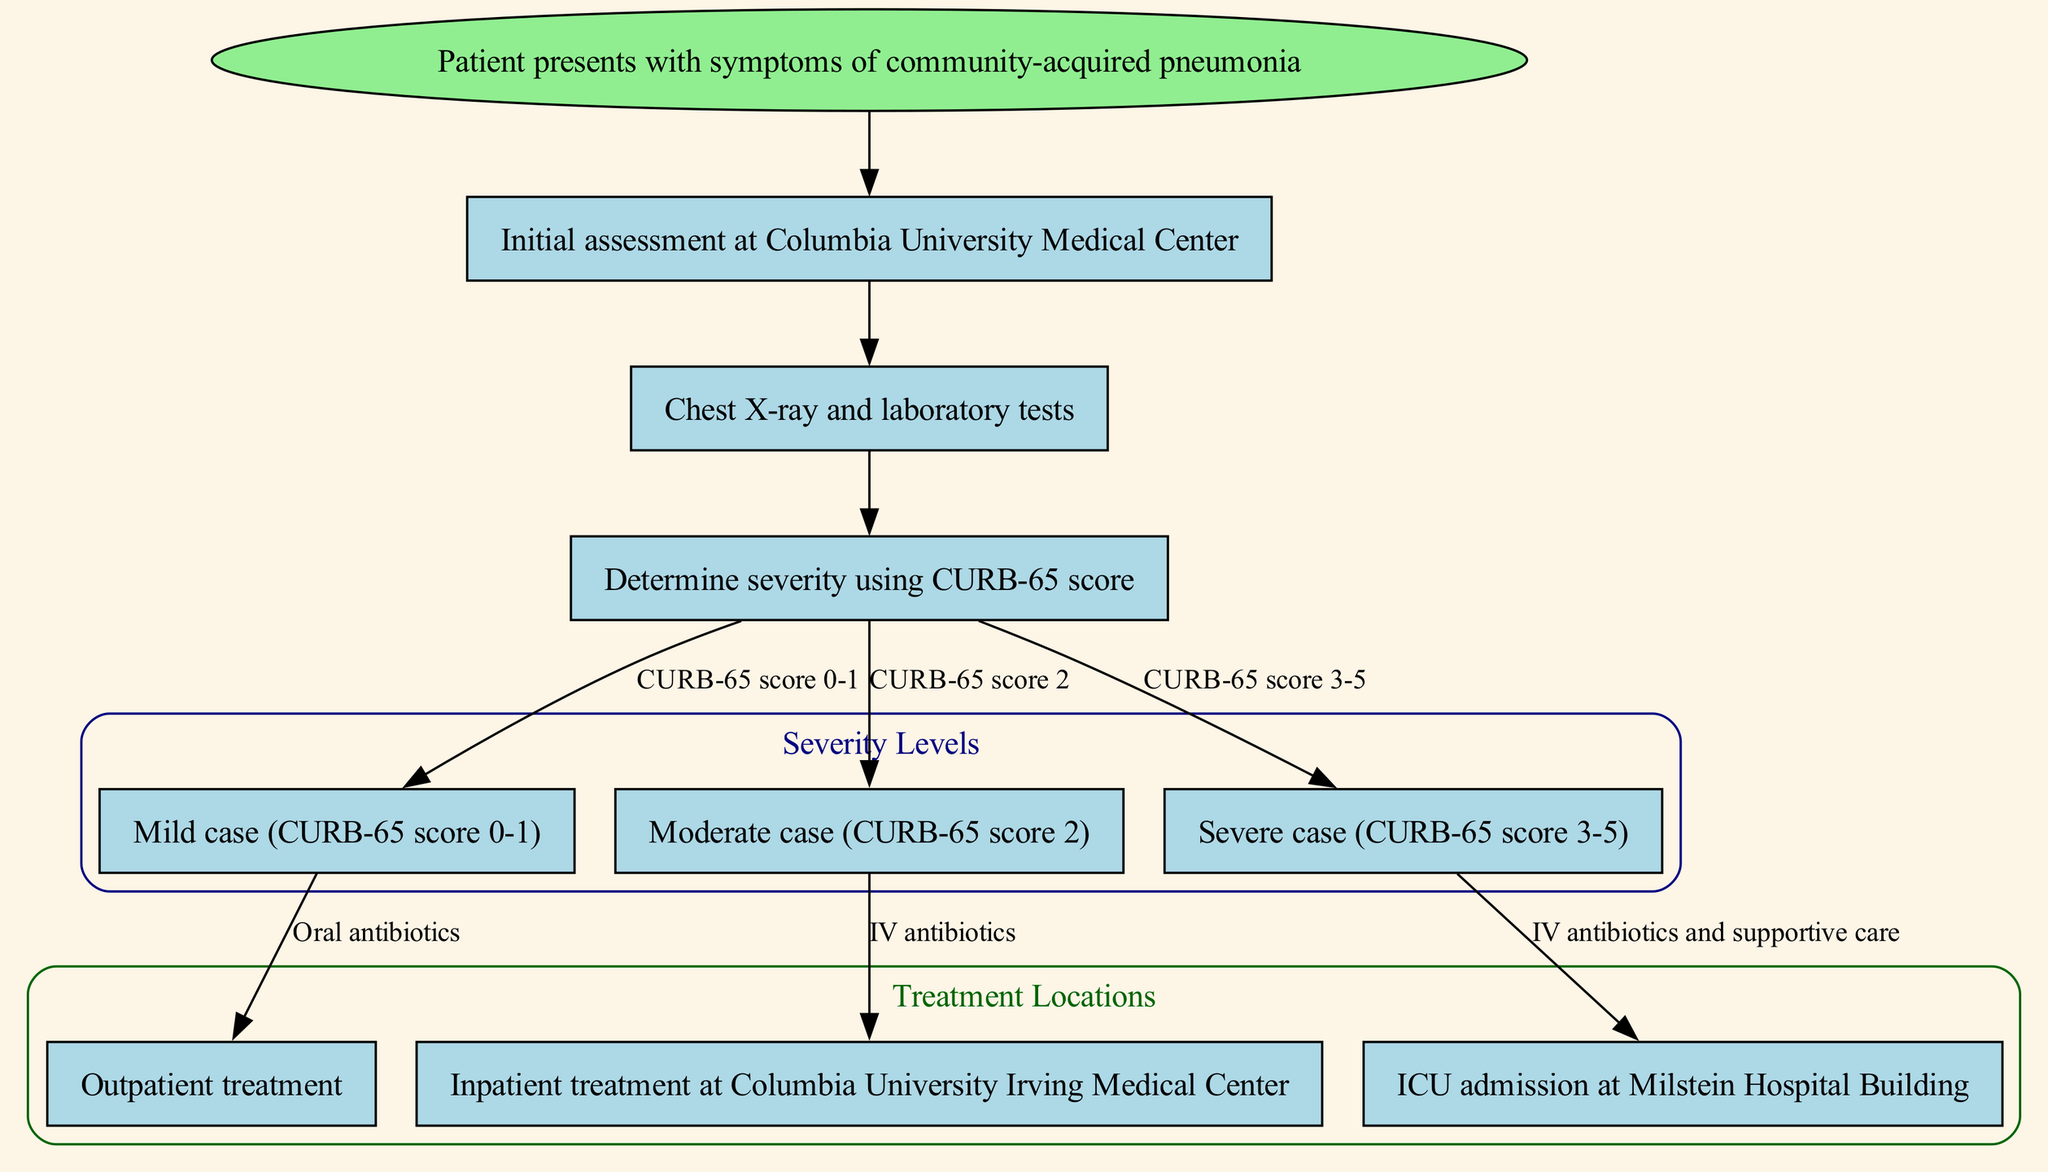What is the first step in the clinical pathway? The clinical pathway begins with "Patient presents with symptoms of community-acquired pneumonia," which indicates the initial point of action for medical staff.
Answer: Patient presents with symptoms of community-acquired pneumonia How many nodes are present in the diagram? Counting each unique node listed, there are eight nodes including the initial patient presentation.
Answer: Eight What are the treatment options for a mild case of pneumonia? According to the pathway, a mild case corresponds to a CURB-65 score of 0-1, and the recommended treatment option is "outpatient treatment" with specific mention of "oral antibiotics."
Answer: Outpatient treatment What is the next step after performing the initial assessment? The diagram clearly indicates that following the initial assessment, the next logical step is conducting "Chest X-ray and laboratory tests."
Answer: Chest X-ray and laboratory tests What CURB-65 score indicates a moderate case of pneumonia? The diagram specifies that a score of 2 on the CURB-65 scale designates a moderate case, showing a clear correlation within its structure.
Answer: CURB-65 score 2 Which treatment is associated with a severe case of pneumonia? For severe cases indicated by a CURB-65 score of 3-5, the diagram specifies that treatment involves "ICU admission" and necessitates "IV antibiotics and supportive care."
Answer: ICU admission What happens if the CURB-65 score is 3 or higher? For scores within the range of 3 to 5 on the CURB-65 scale, the diagram leads to the decision for ICU admission, indicating the severity of condition dictates the level of care required.
Answer: ICU admission What type of antibiotics are prescribed for a moderate case? The pathway indicates that for a moderate case, the prescribed treatment method is "IV antibiotics," which reflects the seriousness of the condition and the need for a more intensive approach.
Answer: IV antibiotics 